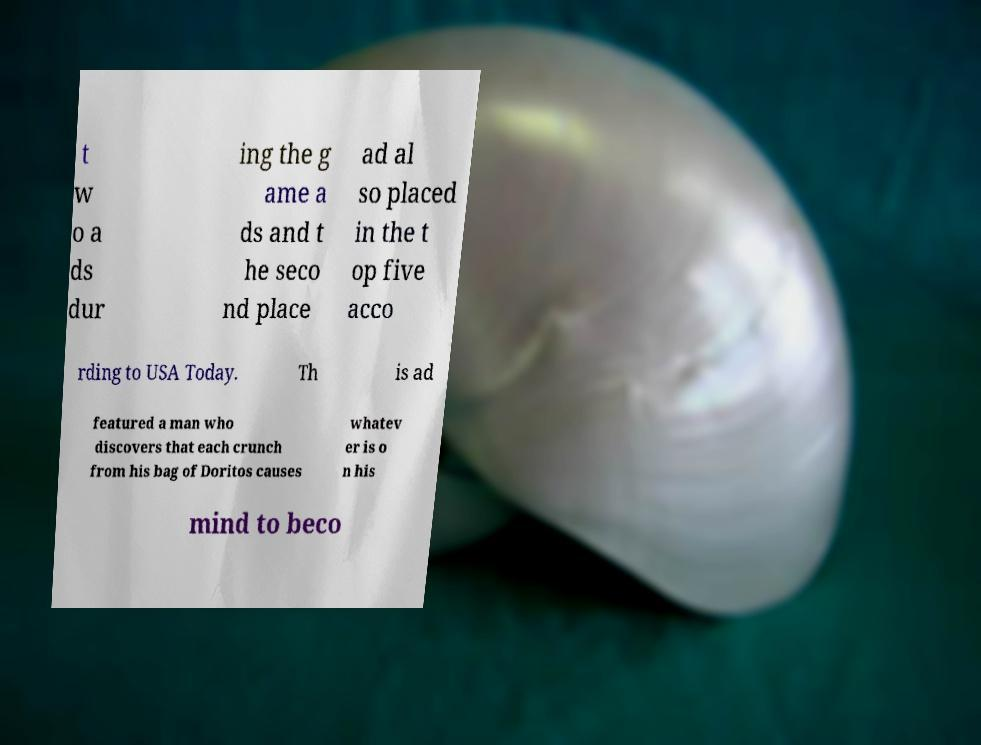What messages or text are displayed in this image? I need them in a readable, typed format. t w o a ds dur ing the g ame a ds and t he seco nd place ad al so placed in the t op five acco rding to USA Today. Th is ad featured a man who discovers that each crunch from his bag of Doritos causes whatev er is o n his mind to beco 